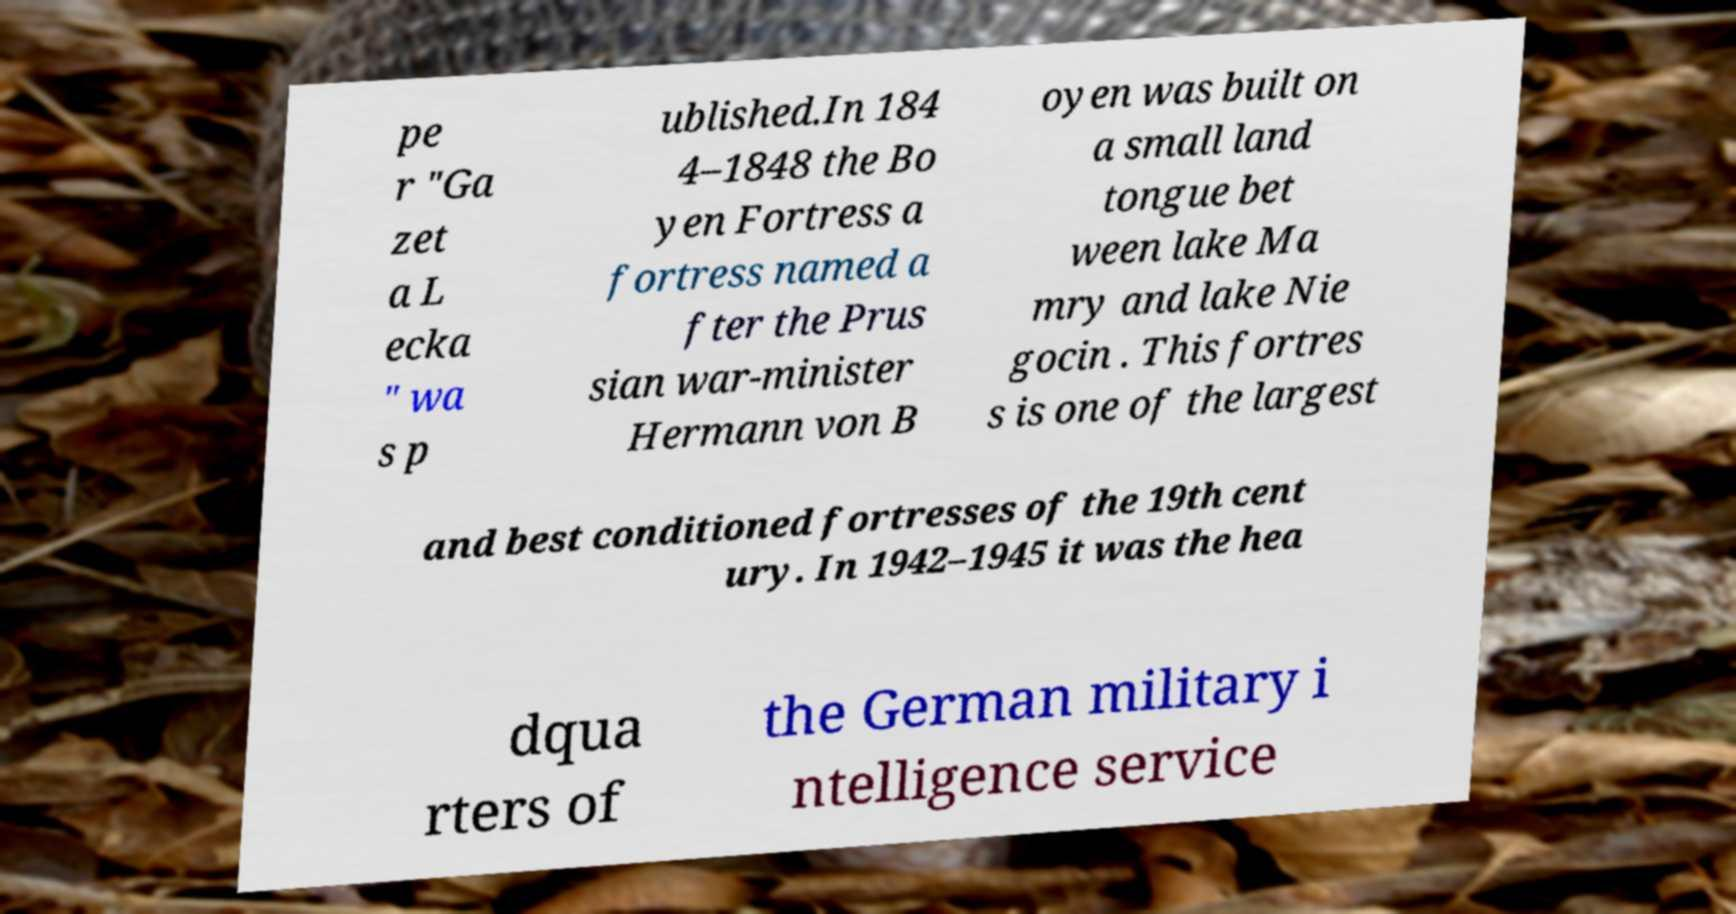Can you accurately transcribe the text from the provided image for me? pe r "Ga zet a L ecka " wa s p ublished.In 184 4–1848 the Bo yen Fortress a fortress named a fter the Prus sian war-minister Hermann von B oyen was built on a small land tongue bet ween lake Ma mry and lake Nie gocin . This fortres s is one of the largest and best conditioned fortresses of the 19th cent ury. In 1942–1945 it was the hea dqua rters of the German military i ntelligence service 